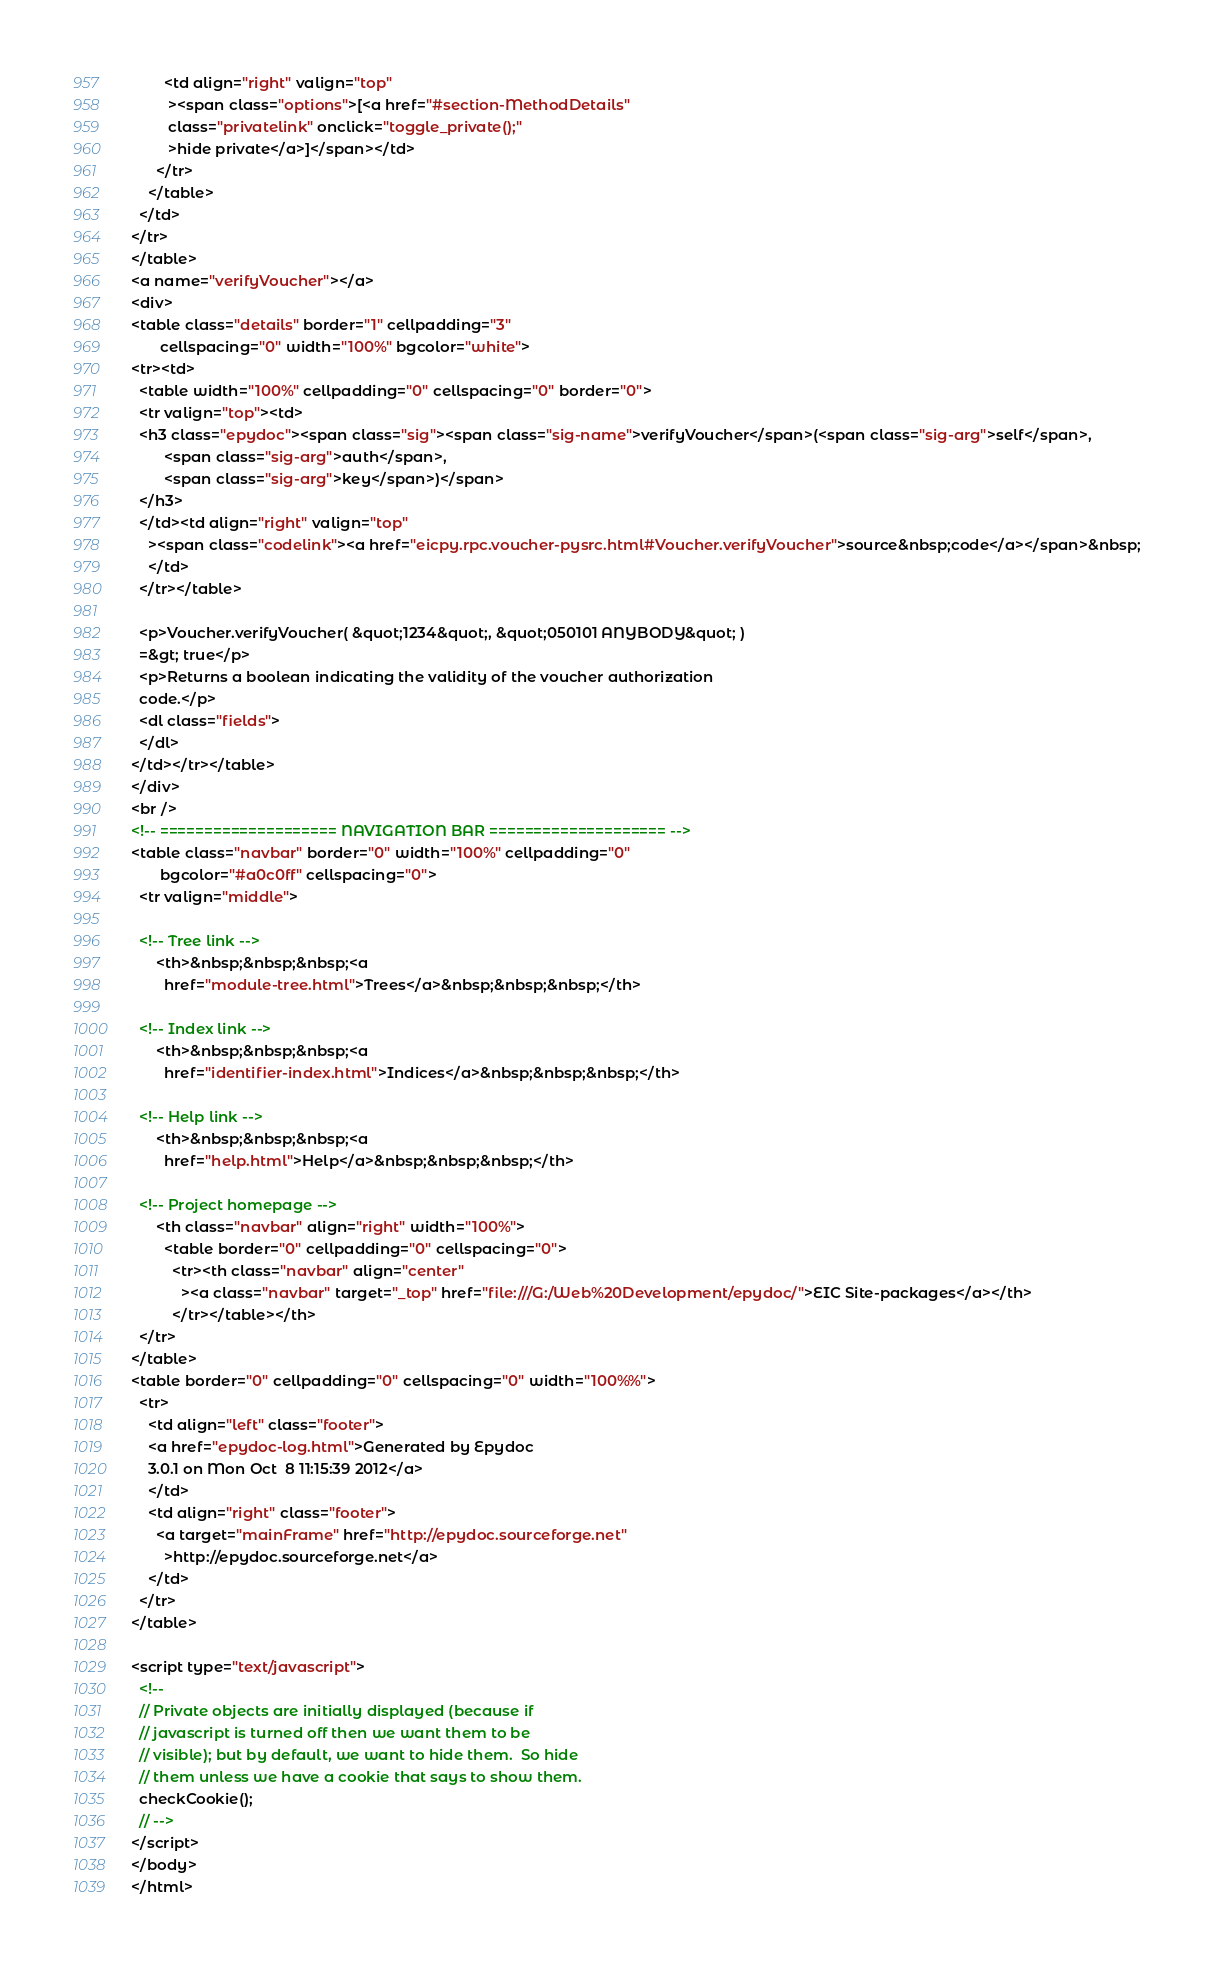<code> <loc_0><loc_0><loc_500><loc_500><_HTML_>        <td align="right" valign="top"
         ><span class="options">[<a href="#section-MethodDetails"
         class="privatelink" onclick="toggle_private();"
         >hide private</a>]</span></td>
      </tr>
    </table>
  </td>
</tr>
</table>
<a name="verifyVoucher"></a>
<div>
<table class="details" border="1" cellpadding="3"
       cellspacing="0" width="100%" bgcolor="white">
<tr><td>
  <table width="100%" cellpadding="0" cellspacing="0" border="0">
  <tr valign="top"><td>
  <h3 class="epydoc"><span class="sig"><span class="sig-name">verifyVoucher</span>(<span class="sig-arg">self</span>,
        <span class="sig-arg">auth</span>,
        <span class="sig-arg">key</span>)</span>
  </h3>
  </td><td align="right" valign="top"
    ><span class="codelink"><a href="eicpy.rpc.voucher-pysrc.html#Voucher.verifyVoucher">source&nbsp;code</a></span>&nbsp;
    </td>
  </tr></table>
  
  <p>Voucher.verifyVoucher( &quot;1234&quot;, &quot;050101 ANYBODY&quot; ) 
  =&gt; true</p>
  <p>Returns a boolean indicating the validity of the voucher authorization
  code.</p>
  <dl class="fields">
  </dl>
</td></tr></table>
</div>
<br />
<!-- ==================== NAVIGATION BAR ==================== -->
<table class="navbar" border="0" width="100%" cellpadding="0"
       bgcolor="#a0c0ff" cellspacing="0">
  <tr valign="middle">

  <!-- Tree link -->
      <th>&nbsp;&nbsp;&nbsp;<a
        href="module-tree.html">Trees</a>&nbsp;&nbsp;&nbsp;</th>

  <!-- Index link -->
      <th>&nbsp;&nbsp;&nbsp;<a
        href="identifier-index.html">Indices</a>&nbsp;&nbsp;&nbsp;</th>

  <!-- Help link -->
      <th>&nbsp;&nbsp;&nbsp;<a
        href="help.html">Help</a>&nbsp;&nbsp;&nbsp;</th>

  <!-- Project homepage -->
      <th class="navbar" align="right" width="100%">
        <table border="0" cellpadding="0" cellspacing="0">
          <tr><th class="navbar" align="center"
            ><a class="navbar" target="_top" href="file:///G:/Web%20Development/epydoc/">EIC Site-packages</a></th>
          </tr></table></th>
  </tr>
</table>
<table border="0" cellpadding="0" cellspacing="0" width="100%%">
  <tr>
    <td align="left" class="footer">
    <a href="epydoc-log.html">Generated by Epydoc
    3.0.1 on Mon Oct  8 11:15:39 2012</a>
    </td>
    <td align="right" class="footer">
      <a target="mainFrame" href="http://epydoc.sourceforge.net"
        >http://epydoc.sourceforge.net</a>
    </td>
  </tr>
</table>

<script type="text/javascript">
  <!--
  // Private objects are initially displayed (because if
  // javascript is turned off then we want them to be
  // visible); but by default, we want to hide them.  So hide
  // them unless we have a cookie that says to show them.
  checkCookie();
  // -->
</script>
</body>
</html>
</code> 